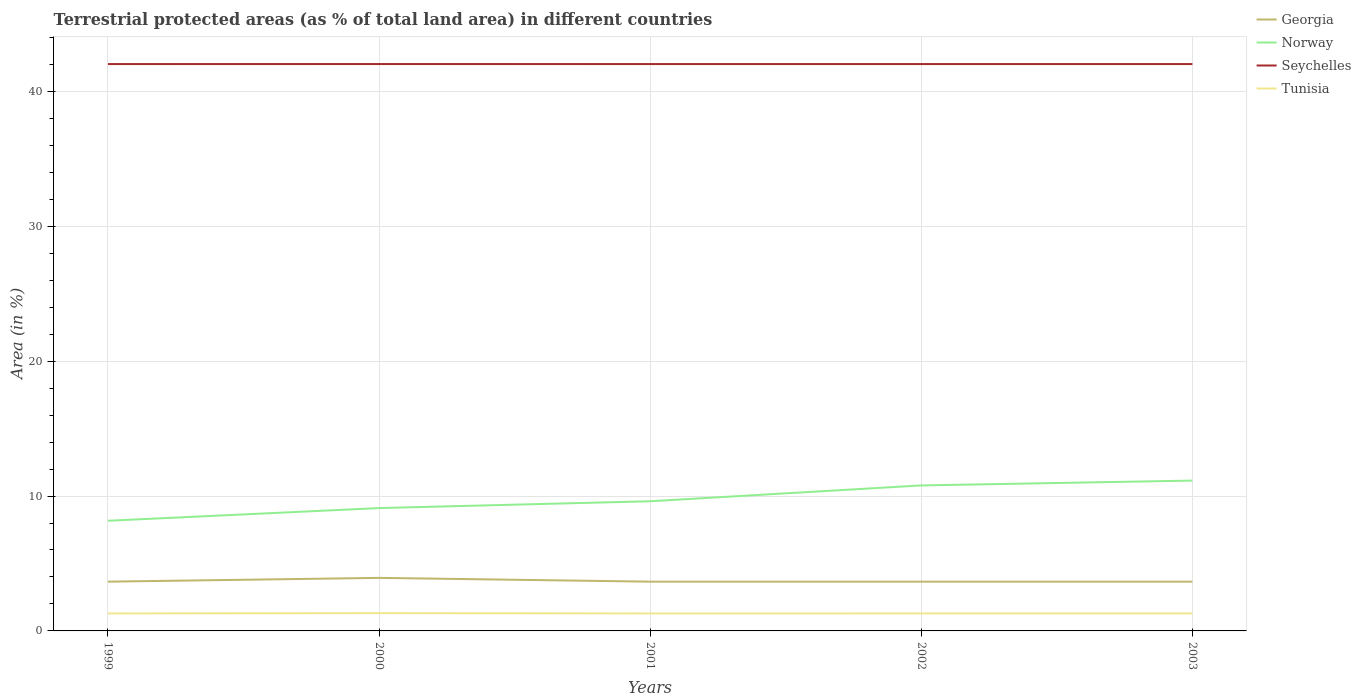How many different coloured lines are there?
Make the answer very short. 4. Across all years, what is the maximum percentage of terrestrial protected land in Tunisia?
Provide a short and direct response. 1.3. What is the total percentage of terrestrial protected land in Seychelles in the graph?
Make the answer very short. -0. What is the difference between the highest and the second highest percentage of terrestrial protected land in Georgia?
Give a very brief answer. 0.28. Is the percentage of terrestrial protected land in Tunisia strictly greater than the percentage of terrestrial protected land in Seychelles over the years?
Your answer should be compact. Yes. How many lines are there?
Provide a short and direct response. 4. Are the values on the major ticks of Y-axis written in scientific E-notation?
Provide a succinct answer. No. Does the graph contain any zero values?
Your response must be concise. No. Where does the legend appear in the graph?
Make the answer very short. Top right. What is the title of the graph?
Your answer should be very brief. Terrestrial protected areas (as % of total land area) in different countries. What is the label or title of the Y-axis?
Your answer should be compact. Area (in %). What is the Area (in %) in Georgia in 1999?
Your response must be concise. 3.65. What is the Area (in %) in Norway in 1999?
Offer a very short reply. 8.17. What is the Area (in %) in Seychelles in 1999?
Make the answer very short. 42.02. What is the Area (in %) of Tunisia in 1999?
Make the answer very short. 1.3. What is the Area (in %) in Georgia in 2000?
Make the answer very short. 3.93. What is the Area (in %) of Norway in 2000?
Your answer should be very brief. 9.11. What is the Area (in %) in Seychelles in 2000?
Offer a very short reply. 42.02. What is the Area (in %) of Tunisia in 2000?
Your response must be concise. 1.32. What is the Area (in %) of Georgia in 2001?
Give a very brief answer. 3.65. What is the Area (in %) in Norway in 2001?
Make the answer very short. 9.61. What is the Area (in %) in Seychelles in 2001?
Keep it short and to the point. 42.02. What is the Area (in %) of Tunisia in 2001?
Your answer should be compact. 1.3. What is the Area (in %) of Georgia in 2002?
Provide a short and direct response. 3.65. What is the Area (in %) of Norway in 2002?
Provide a succinct answer. 10.79. What is the Area (in %) of Seychelles in 2002?
Provide a succinct answer. 42.02. What is the Area (in %) of Tunisia in 2002?
Ensure brevity in your answer.  1.3. What is the Area (in %) in Georgia in 2003?
Ensure brevity in your answer.  3.65. What is the Area (in %) of Norway in 2003?
Your answer should be compact. 11.14. What is the Area (in %) in Seychelles in 2003?
Offer a terse response. 42.02. What is the Area (in %) of Tunisia in 2003?
Keep it short and to the point. 1.3. Across all years, what is the maximum Area (in %) of Georgia?
Keep it short and to the point. 3.93. Across all years, what is the maximum Area (in %) of Norway?
Your answer should be compact. 11.14. Across all years, what is the maximum Area (in %) of Seychelles?
Provide a succinct answer. 42.02. Across all years, what is the maximum Area (in %) of Tunisia?
Make the answer very short. 1.32. Across all years, what is the minimum Area (in %) in Georgia?
Offer a very short reply. 3.65. Across all years, what is the minimum Area (in %) in Norway?
Keep it short and to the point. 8.17. Across all years, what is the minimum Area (in %) in Seychelles?
Your response must be concise. 42.02. Across all years, what is the minimum Area (in %) in Tunisia?
Offer a terse response. 1.3. What is the total Area (in %) in Georgia in the graph?
Give a very brief answer. 18.54. What is the total Area (in %) in Norway in the graph?
Ensure brevity in your answer.  48.82. What is the total Area (in %) in Seychelles in the graph?
Ensure brevity in your answer.  210.11. What is the total Area (in %) of Tunisia in the graph?
Provide a short and direct response. 6.5. What is the difference between the Area (in %) of Georgia in 1999 and that in 2000?
Offer a terse response. -0.28. What is the difference between the Area (in %) in Norway in 1999 and that in 2000?
Offer a terse response. -0.94. What is the difference between the Area (in %) in Seychelles in 1999 and that in 2000?
Offer a terse response. -0. What is the difference between the Area (in %) in Tunisia in 1999 and that in 2000?
Provide a succinct answer. -0.02. What is the difference between the Area (in %) in Norway in 1999 and that in 2001?
Provide a succinct answer. -1.45. What is the difference between the Area (in %) of Norway in 1999 and that in 2002?
Offer a very short reply. -2.62. What is the difference between the Area (in %) of Seychelles in 1999 and that in 2002?
Make the answer very short. 0. What is the difference between the Area (in %) in Tunisia in 1999 and that in 2002?
Your answer should be very brief. -0. What is the difference between the Area (in %) of Georgia in 1999 and that in 2003?
Offer a very short reply. 0. What is the difference between the Area (in %) of Norway in 1999 and that in 2003?
Your response must be concise. -2.98. What is the difference between the Area (in %) of Tunisia in 1999 and that in 2003?
Your answer should be very brief. -0. What is the difference between the Area (in %) in Georgia in 2000 and that in 2001?
Ensure brevity in your answer.  0.28. What is the difference between the Area (in %) in Norway in 2000 and that in 2001?
Offer a very short reply. -0.51. What is the difference between the Area (in %) in Seychelles in 2000 and that in 2001?
Give a very brief answer. 0. What is the difference between the Area (in %) of Tunisia in 2000 and that in 2001?
Your response must be concise. 0.02. What is the difference between the Area (in %) of Georgia in 2000 and that in 2002?
Give a very brief answer. 0.28. What is the difference between the Area (in %) of Norway in 2000 and that in 2002?
Offer a terse response. -1.68. What is the difference between the Area (in %) of Seychelles in 2000 and that in 2002?
Make the answer very short. 0. What is the difference between the Area (in %) in Tunisia in 2000 and that in 2002?
Offer a terse response. 0.02. What is the difference between the Area (in %) in Georgia in 2000 and that in 2003?
Ensure brevity in your answer.  0.28. What is the difference between the Area (in %) in Norway in 2000 and that in 2003?
Provide a short and direct response. -2.04. What is the difference between the Area (in %) in Seychelles in 2000 and that in 2003?
Provide a succinct answer. 0. What is the difference between the Area (in %) of Tunisia in 2000 and that in 2003?
Make the answer very short. 0.02. What is the difference between the Area (in %) in Norway in 2001 and that in 2002?
Provide a short and direct response. -1.17. What is the difference between the Area (in %) of Tunisia in 2001 and that in 2002?
Your answer should be compact. -0. What is the difference between the Area (in %) of Norway in 2001 and that in 2003?
Provide a short and direct response. -1.53. What is the difference between the Area (in %) of Tunisia in 2001 and that in 2003?
Give a very brief answer. -0. What is the difference between the Area (in %) in Georgia in 2002 and that in 2003?
Offer a terse response. 0. What is the difference between the Area (in %) in Norway in 2002 and that in 2003?
Ensure brevity in your answer.  -0.36. What is the difference between the Area (in %) in Seychelles in 2002 and that in 2003?
Give a very brief answer. 0. What is the difference between the Area (in %) in Tunisia in 2002 and that in 2003?
Keep it short and to the point. 0. What is the difference between the Area (in %) in Georgia in 1999 and the Area (in %) in Norway in 2000?
Keep it short and to the point. -5.45. What is the difference between the Area (in %) in Georgia in 1999 and the Area (in %) in Seychelles in 2000?
Ensure brevity in your answer.  -38.37. What is the difference between the Area (in %) of Georgia in 1999 and the Area (in %) of Tunisia in 2000?
Give a very brief answer. 2.34. What is the difference between the Area (in %) of Norway in 1999 and the Area (in %) of Seychelles in 2000?
Offer a very short reply. -33.86. What is the difference between the Area (in %) in Norway in 1999 and the Area (in %) in Tunisia in 2000?
Provide a succinct answer. 6.85. What is the difference between the Area (in %) in Seychelles in 1999 and the Area (in %) in Tunisia in 2000?
Give a very brief answer. 40.7. What is the difference between the Area (in %) in Georgia in 1999 and the Area (in %) in Norway in 2001?
Offer a very short reply. -5.96. What is the difference between the Area (in %) of Georgia in 1999 and the Area (in %) of Seychelles in 2001?
Offer a terse response. -38.37. What is the difference between the Area (in %) in Georgia in 1999 and the Area (in %) in Tunisia in 2001?
Give a very brief answer. 2.36. What is the difference between the Area (in %) of Norway in 1999 and the Area (in %) of Seychelles in 2001?
Your response must be concise. -33.86. What is the difference between the Area (in %) in Norway in 1999 and the Area (in %) in Tunisia in 2001?
Ensure brevity in your answer.  6.87. What is the difference between the Area (in %) in Seychelles in 1999 and the Area (in %) in Tunisia in 2001?
Provide a short and direct response. 40.73. What is the difference between the Area (in %) of Georgia in 1999 and the Area (in %) of Norway in 2002?
Your answer should be very brief. -7.13. What is the difference between the Area (in %) of Georgia in 1999 and the Area (in %) of Seychelles in 2002?
Your answer should be very brief. -38.37. What is the difference between the Area (in %) of Georgia in 1999 and the Area (in %) of Tunisia in 2002?
Give a very brief answer. 2.36. What is the difference between the Area (in %) of Norway in 1999 and the Area (in %) of Seychelles in 2002?
Offer a terse response. -33.86. What is the difference between the Area (in %) in Norway in 1999 and the Area (in %) in Tunisia in 2002?
Your response must be concise. 6.87. What is the difference between the Area (in %) of Seychelles in 1999 and the Area (in %) of Tunisia in 2002?
Make the answer very short. 40.73. What is the difference between the Area (in %) in Georgia in 1999 and the Area (in %) in Norway in 2003?
Your answer should be very brief. -7.49. What is the difference between the Area (in %) of Georgia in 1999 and the Area (in %) of Seychelles in 2003?
Offer a terse response. -38.37. What is the difference between the Area (in %) of Georgia in 1999 and the Area (in %) of Tunisia in 2003?
Make the answer very short. 2.36. What is the difference between the Area (in %) of Norway in 1999 and the Area (in %) of Seychelles in 2003?
Give a very brief answer. -33.86. What is the difference between the Area (in %) in Norway in 1999 and the Area (in %) in Tunisia in 2003?
Offer a terse response. 6.87. What is the difference between the Area (in %) in Seychelles in 1999 and the Area (in %) in Tunisia in 2003?
Provide a succinct answer. 40.73. What is the difference between the Area (in %) in Georgia in 2000 and the Area (in %) in Norway in 2001?
Give a very brief answer. -5.68. What is the difference between the Area (in %) of Georgia in 2000 and the Area (in %) of Seychelles in 2001?
Give a very brief answer. -38.09. What is the difference between the Area (in %) of Georgia in 2000 and the Area (in %) of Tunisia in 2001?
Offer a terse response. 2.64. What is the difference between the Area (in %) in Norway in 2000 and the Area (in %) in Seychelles in 2001?
Your answer should be very brief. -32.92. What is the difference between the Area (in %) of Norway in 2000 and the Area (in %) of Tunisia in 2001?
Give a very brief answer. 7.81. What is the difference between the Area (in %) of Seychelles in 2000 and the Area (in %) of Tunisia in 2001?
Keep it short and to the point. 40.73. What is the difference between the Area (in %) of Georgia in 2000 and the Area (in %) of Norway in 2002?
Your response must be concise. -6.85. What is the difference between the Area (in %) of Georgia in 2000 and the Area (in %) of Seychelles in 2002?
Your response must be concise. -38.09. What is the difference between the Area (in %) of Georgia in 2000 and the Area (in %) of Tunisia in 2002?
Offer a very short reply. 2.64. What is the difference between the Area (in %) of Norway in 2000 and the Area (in %) of Seychelles in 2002?
Give a very brief answer. -32.92. What is the difference between the Area (in %) of Norway in 2000 and the Area (in %) of Tunisia in 2002?
Give a very brief answer. 7.81. What is the difference between the Area (in %) in Seychelles in 2000 and the Area (in %) in Tunisia in 2002?
Your answer should be compact. 40.73. What is the difference between the Area (in %) of Georgia in 2000 and the Area (in %) of Norway in 2003?
Offer a terse response. -7.21. What is the difference between the Area (in %) of Georgia in 2000 and the Area (in %) of Seychelles in 2003?
Give a very brief answer. -38.09. What is the difference between the Area (in %) of Georgia in 2000 and the Area (in %) of Tunisia in 2003?
Give a very brief answer. 2.64. What is the difference between the Area (in %) in Norway in 2000 and the Area (in %) in Seychelles in 2003?
Offer a terse response. -32.92. What is the difference between the Area (in %) in Norway in 2000 and the Area (in %) in Tunisia in 2003?
Provide a succinct answer. 7.81. What is the difference between the Area (in %) in Seychelles in 2000 and the Area (in %) in Tunisia in 2003?
Your answer should be very brief. 40.73. What is the difference between the Area (in %) in Georgia in 2001 and the Area (in %) in Norway in 2002?
Provide a succinct answer. -7.13. What is the difference between the Area (in %) in Georgia in 2001 and the Area (in %) in Seychelles in 2002?
Give a very brief answer. -38.37. What is the difference between the Area (in %) of Georgia in 2001 and the Area (in %) of Tunisia in 2002?
Give a very brief answer. 2.36. What is the difference between the Area (in %) in Norway in 2001 and the Area (in %) in Seychelles in 2002?
Your answer should be compact. -32.41. What is the difference between the Area (in %) in Norway in 2001 and the Area (in %) in Tunisia in 2002?
Your answer should be very brief. 8.32. What is the difference between the Area (in %) of Seychelles in 2001 and the Area (in %) of Tunisia in 2002?
Provide a short and direct response. 40.73. What is the difference between the Area (in %) of Georgia in 2001 and the Area (in %) of Norway in 2003?
Offer a terse response. -7.49. What is the difference between the Area (in %) in Georgia in 2001 and the Area (in %) in Seychelles in 2003?
Offer a terse response. -38.37. What is the difference between the Area (in %) of Georgia in 2001 and the Area (in %) of Tunisia in 2003?
Ensure brevity in your answer.  2.36. What is the difference between the Area (in %) of Norway in 2001 and the Area (in %) of Seychelles in 2003?
Offer a very short reply. -32.41. What is the difference between the Area (in %) of Norway in 2001 and the Area (in %) of Tunisia in 2003?
Keep it short and to the point. 8.32. What is the difference between the Area (in %) of Seychelles in 2001 and the Area (in %) of Tunisia in 2003?
Your response must be concise. 40.73. What is the difference between the Area (in %) of Georgia in 2002 and the Area (in %) of Norway in 2003?
Keep it short and to the point. -7.49. What is the difference between the Area (in %) of Georgia in 2002 and the Area (in %) of Seychelles in 2003?
Offer a very short reply. -38.37. What is the difference between the Area (in %) of Georgia in 2002 and the Area (in %) of Tunisia in 2003?
Your answer should be compact. 2.36. What is the difference between the Area (in %) of Norway in 2002 and the Area (in %) of Seychelles in 2003?
Your response must be concise. -31.24. What is the difference between the Area (in %) of Norway in 2002 and the Area (in %) of Tunisia in 2003?
Provide a short and direct response. 9.49. What is the difference between the Area (in %) of Seychelles in 2002 and the Area (in %) of Tunisia in 2003?
Provide a short and direct response. 40.73. What is the average Area (in %) in Georgia per year?
Make the answer very short. 3.71. What is the average Area (in %) in Norway per year?
Provide a succinct answer. 9.76. What is the average Area (in %) in Seychelles per year?
Your answer should be compact. 42.02. What is the average Area (in %) of Tunisia per year?
Ensure brevity in your answer.  1.3. In the year 1999, what is the difference between the Area (in %) in Georgia and Area (in %) in Norway?
Ensure brevity in your answer.  -4.51. In the year 1999, what is the difference between the Area (in %) in Georgia and Area (in %) in Seychelles?
Make the answer very short. -38.37. In the year 1999, what is the difference between the Area (in %) in Georgia and Area (in %) in Tunisia?
Give a very brief answer. 2.36. In the year 1999, what is the difference between the Area (in %) in Norway and Area (in %) in Seychelles?
Keep it short and to the point. -33.86. In the year 1999, what is the difference between the Area (in %) of Norway and Area (in %) of Tunisia?
Provide a succinct answer. 6.87. In the year 1999, what is the difference between the Area (in %) in Seychelles and Area (in %) in Tunisia?
Give a very brief answer. 40.73. In the year 2000, what is the difference between the Area (in %) in Georgia and Area (in %) in Norway?
Keep it short and to the point. -5.17. In the year 2000, what is the difference between the Area (in %) of Georgia and Area (in %) of Seychelles?
Provide a succinct answer. -38.09. In the year 2000, what is the difference between the Area (in %) in Georgia and Area (in %) in Tunisia?
Your response must be concise. 2.62. In the year 2000, what is the difference between the Area (in %) in Norway and Area (in %) in Seychelles?
Offer a very short reply. -32.92. In the year 2000, what is the difference between the Area (in %) of Norway and Area (in %) of Tunisia?
Your response must be concise. 7.79. In the year 2000, what is the difference between the Area (in %) of Seychelles and Area (in %) of Tunisia?
Your answer should be very brief. 40.71. In the year 2001, what is the difference between the Area (in %) of Georgia and Area (in %) of Norway?
Keep it short and to the point. -5.96. In the year 2001, what is the difference between the Area (in %) of Georgia and Area (in %) of Seychelles?
Your response must be concise. -38.37. In the year 2001, what is the difference between the Area (in %) of Georgia and Area (in %) of Tunisia?
Your response must be concise. 2.36. In the year 2001, what is the difference between the Area (in %) of Norway and Area (in %) of Seychelles?
Provide a succinct answer. -32.41. In the year 2001, what is the difference between the Area (in %) of Norway and Area (in %) of Tunisia?
Ensure brevity in your answer.  8.32. In the year 2001, what is the difference between the Area (in %) of Seychelles and Area (in %) of Tunisia?
Provide a succinct answer. 40.73. In the year 2002, what is the difference between the Area (in %) of Georgia and Area (in %) of Norway?
Keep it short and to the point. -7.13. In the year 2002, what is the difference between the Area (in %) in Georgia and Area (in %) in Seychelles?
Give a very brief answer. -38.37. In the year 2002, what is the difference between the Area (in %) in Georgia and Area (in %) in Tunisia?
Offer a very short reply. 2.36. In the year 2002, what is the difference between the Area (in %) of Norway and Area (in %) of Seychelles?
Provide a succinct answer. -31.24. In the year 2002, what is the difference between the Area (in %) of Norway and Area (in %) of Tunisia?
Offer a terse response. 9.49. In the year 2002, what is the difference between the Area (in %) in Seychelles and Area (in %) in Tunisia?
Ensure brevity in your answer.  40.73. In the year 2003, what is the difference between the Area (in %) in Georgia and Area (in %) in Norway?
Ensure brevity in your answer.  -7.49. In the year 2003, what is the difference between the Area (in %) of Georgia and Area (in %) of Seychelles?
Offer a terse response. -38.37. In the year 2003, what is the difference between the Area (in %) of Georgia and Area (in %) of Tunisia?
Provide a succinct answer. 2.36. In the year 2003, what is the difference between the Area (in %) in Norway and Area (in %) in Seychelles?
Offer a terse response. -30.88. In the year 2003, what is the difference between the Area (in %) in Norway and Area (in %) in Tunisia?
Offer a very short reply. 9.85. In the year 2003, what is the difference between the Area (in %) in Seychelles and Area (in %) in Tunisia?
Offer a very short reply. 40.73. What is the ratio of the Area (in %) of Georgia in 1999 to that in 2000?
Ensure brevity in your answer.  0.93. What is the ratio of the Area (in %) in Norway in 1999 to that in 2000?
Ensure brevity in your answer.  0.9. What is the ratio of the Area (in %) in Seychelles in 1999 to that in 2000?
Provide a succinct answer. 1. What is the ratio of the Area (in %) of Tunisia in 1999 to that in 2000?
Your answer should be very brief. 0.98. What is the ratio of the Area (in %) of Norway in 1999 to that in 2001?
Offer a very short reply. 0.85. What is the ratio of the Area (in %) of Seychelles in 1999 to that in 2001?
Your answer should be compact. 1. What is the ratio of the Area (in %) of Tunisia in 1999 to that in 2001?
Your answer should be compact. 1. What is the ratio of the Area (in %) in Georgia in 1999 to that in 2002?
Your answer should be very brief. 1. What is the ratio of the Area (in %) in Norway in 1999 to that in 2002?
Ensure brevity in your answer.  0.76. What is the ratio of the Area (in %) in Norway in 1999 to that in 2003?
Offer a very short reply. 0.73. What is the ratio of the Area (in %) of Seychelles in 1999 to that in 2003?
Offer a terse response. 1. What is the ratio of the Area (in %) in Tunisia in 1999 to that in 2003?
Provide a succinct answer. 1. What is the ratio of the Area (in %) of Georgia in 2000 to that in 2001?
Make the answer very short. 1.08. What is the ratio of the Area (in %) of Norway in 2000 to that in 2001?
Offer a terse response. 0.95. What is the ratio of the Area (in %) in Seychelles in 2000 to that in 2001?
Provide a short and direct response. 1. What is the ratio of the Area (in %) in Tunisia in 2000 to that in 2001?
Offer a very short reply. 1.02. What is the ratio of the Area (in %) of Georgia in 2000 to that in 2002?
Your answer should be very brief. 1.08. What is the ratio of the Area (in %) in Norway in 2000 to that in 2002?
Provide a succinct answer. 0.84. What is the ratio of the Area (in %) in Tunisia in 2000 to that in 2002?
Your answer should be very brief. 1.02. What is the ratio of the Area (in %) in Georgia in 2000 to that in 2003?
Offer a very short reply. 1.08. What is the ratio of the Area (in %) of Norway in 2000 to that in 2003?
Keep it short and to the point. 0.82. What is the ratio of the Area (in %) in Tunisia in 2000 to that in 2003?
Give a very brief answer. 1.02. What is the ratio of the Area (in %) of Georgia in 2001 to that in 2002?
Your answer should be very brief. 1. What is the ratio of the Area (in %) in Norway in 2001 to that in 2002?
Your response must be concise. 0.89. What is the ratio of the Area (in %) of Georgia in 2001 to that in 2003?
Keep it short and to the point. 1. What is the ratio of the Area (in %) of Norway in 2001 to that in 2003?
Offer a terse response. 0.86. What is the ratio of the Area (in %) of Tunisia in 2001 to that in 2003?
Your answer should be very brief. 1. What is the ratio of the Area (in %) of Georgia in 2002 to that in 2003?
Offer a terse response. 1. What is the ratio of the Area (in %) in Norway in 2002 to that in 2003?
Offer a terse response. 0.97. What is the ratio of the Area (in %) of Seychelles in 2002 to that in 2003?
Make the answer very short. 1. What is the difference between the highest and the second highest Area (in %) of Georgia?
Offer a very short reply. 0.28. What is the difference between the highest and the second highest Area (in %) of Norway?
Give a very brief answer. 0.36. What is the difference between the highest and the second highest Area (in %) in Seychelles?
Ensure brevity in your answer.  0. What is the difference between the highest and the second highest Area (in %) in Tunisia?
Keep it short and to the point. 0.02. What is the difference between the highest and the lowest Area (in %) of Georgia?
Your answer should be compact. 0.28. What is the difference between the highest and the lowest Area (in %) in Norway?
Your answer should be very brief. 2.98. What is the difference between the highest and the lowest Area (in %) in Seychelles?
Offer a very short reply. 0. What is the difference between the highest and the lowest Area (in %) of Tunisia?
Offer a very short reply. 0.02. 